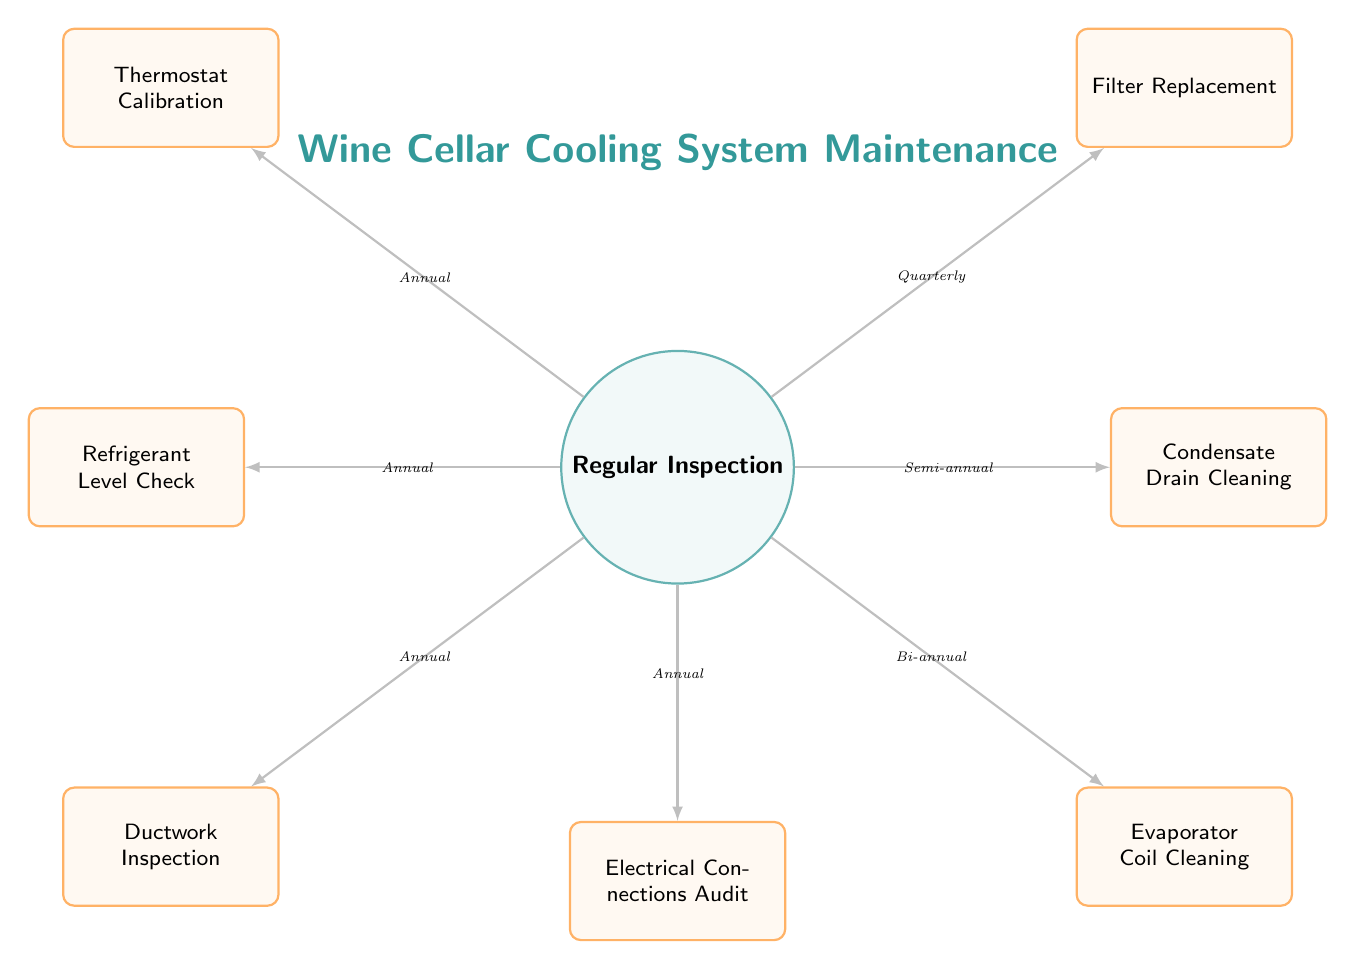What is the main focus of the diagram? The main focus is on the "Wine Cellar Cooling System Maintenance" as indicated at the top of the diagram.
Answer: Wine Cellar Cooling System Maintenance How many maintenance tasks are listed in the diagram? The diagram displays a total of seven maintenance tasks branching from the "Regular Inspection" node.
Answer: Seven Which maintenance task requires action every quarter? The task listed to be performed quarterly is "Filter Replacement," as indicated next to that task.
Answer: Filter Replacement What is the frequency of "Electrical Connections Audit"? The diagram specifies that the "Electrical Connections Audit" should be conducted annually.
Answer: Annual Which tasks are categorized under Semi-annual maintenance? The "Condensate Drain Cleaning" task is the only one marked for semi-annual maintenance in the diagram.
Answer: Condensate Drain Cleaning If one were to perform all maintenance tasks, how many are annual? There are four tasks labeled as annual, which include "Thermostat Calibration," "Refrigerant Level Check," "Ductwork Inspection," and "Electrical Connections Audit."
Answer: Four What type of shape represents the main node? The main node is represented by a circle shape, which indicates its central importance in the maintenance schedule.
Answer: Circle How does "Ductwork Inspection" relate to "Refrigerant Level Check"? Both "Ductwork Inspection" and "Refrigerant Level Check" are categorized under annual maintenance tasks, showing that they occur in the same frequency category.
Answer: Annual 